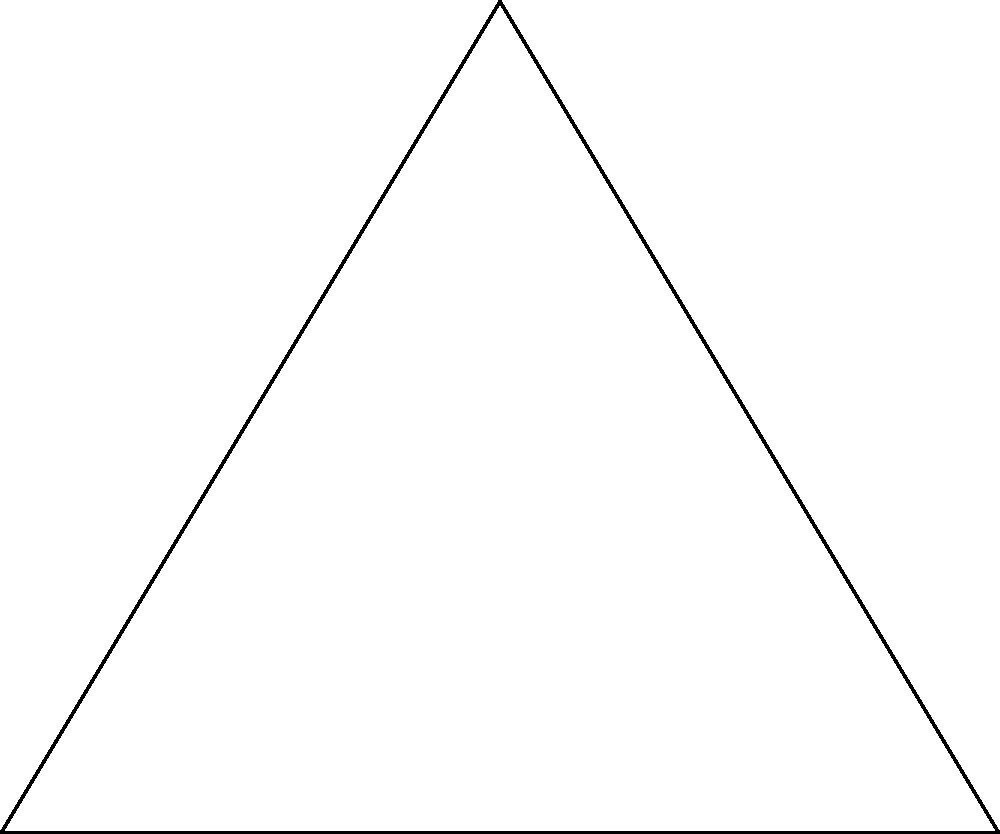To maximize 5G coverage, the town plans to place a cell tower that can serve the three main districts represented by points A, B, and C. If the optimal location for the tower is at point O, which is equidistant from A, B, and C, what is the ratio of the area of the circle (representing the tower's coverage) to the area of triangle ABC? Let's approach this step-by-step:

1) The point O is the circumcenter of triangle ABC, as it's equidistant from A, B, and C.

2) The radius of the circle (R) is the distance from O to any of the triangle's vertices.

3) To find the area of the circle, we need R². We can use the formula for the circumradius of a triangle:

   $$R = \frac{abc}{4A}$$

   where a, b, c are the side lengths of the triangle and A is its area.

4) The area of the circle is $$\pi R^2 = \pi (\frac{abc}{4A})^2$$

5) The ratio of the circle's area to the triangle's area is:

   $$\frac{\text{Area of Circle}}{\text{Area of Triangle}} = \frac{\pi (\frac{abc}{4A})^2}{A} = \frac{\pi a^2b^2c^2}{16A^3}$$

6) We can simplify this using Heron's formula for the area of a triangle:

   $$A = \sqrt{s(s-a)(s-b)(s-c)}$$

   where $s = \frac{a+b+c}{2}$ (semi-perimeter)

7) Substituting this into our ratio:

   $$\frac{\pi a^2b^2c^2}{16(\sqrt{s(s-a)(s-b)(s-c)})^3}$$

8) This can be further simplified to:

   $$\frac{\pi R^2}{A} = \frac{\pi}{4 \sin A \sin B \sin C}$$

   where A, B, C are the angles of the triangle.
Answer: $\frac{\pi}{4 \sin A \sin B \sin C}$ 